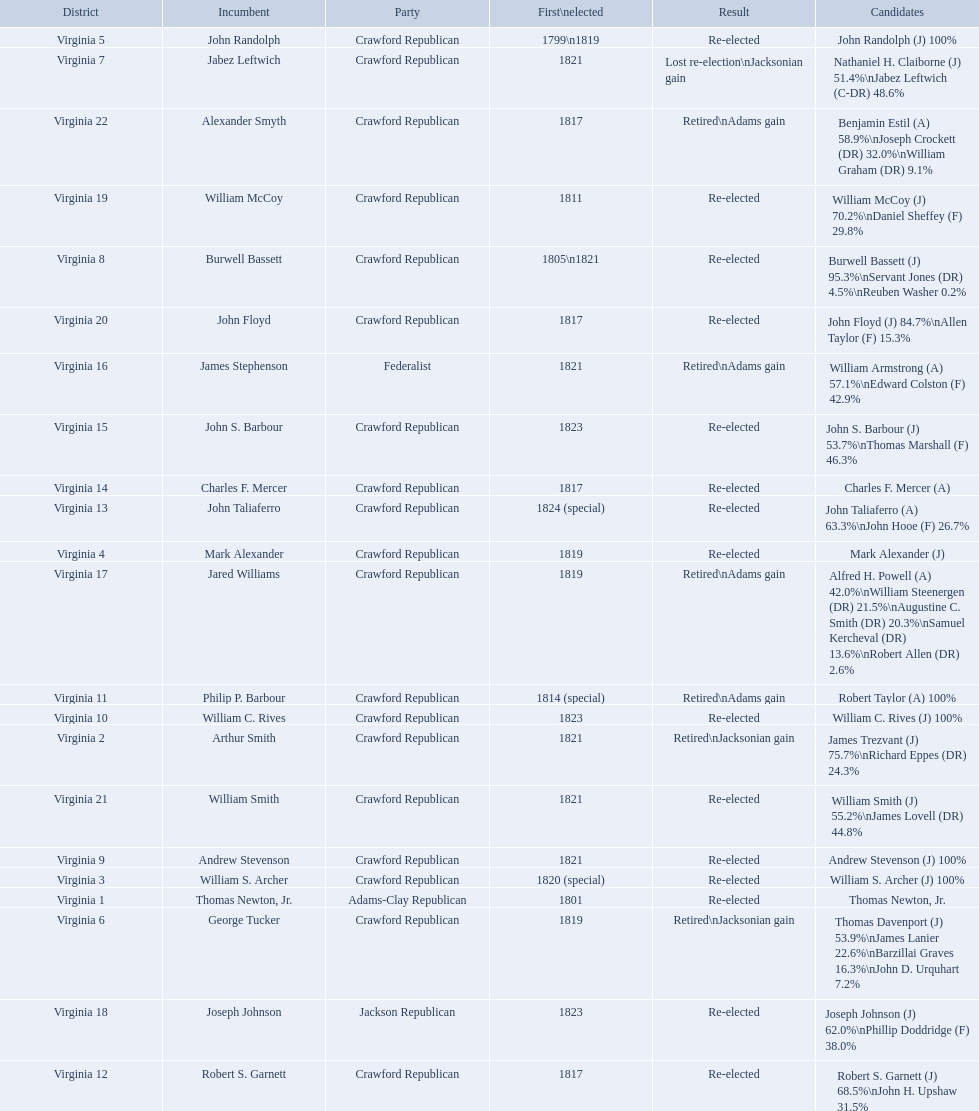What party is a crawford republican? Crawford Republican, Crawford Republican, Crawford Republican, Crawford Republican, Crawford Republican, Crawford Republican, Crawford Republican, Crawford Republican, Crawford Republican, Crawford Republican, Crawford Republican, Crawford Republican, Crawford Republican, Crawford Republican, Crawford Republican, Crawford Republican, Crawford Republican, Crawford Republican, Crawford Republican. What candidates have over 76%? James Trezvant (J) 75.7%\nRichard Eppes (DR) 24.3%, William S. Archer (J) 100%, John Randolph (J) 100%, Burwell Bassett (J) 95.3%\nServant Jones (DR) 4.5%\nReuben Washer 0.2%, Andrew Stevenson (J) 100%, William C. Rives (J) 100%, Robert Taylor (A) 100%, John Floyd (J) 84.7%\nAllen Taylor (F) 15.3%. Which result was retired jacksonian gain? Retired\nJacksonian gain. Who was the incumbent? Arthur Smith. 